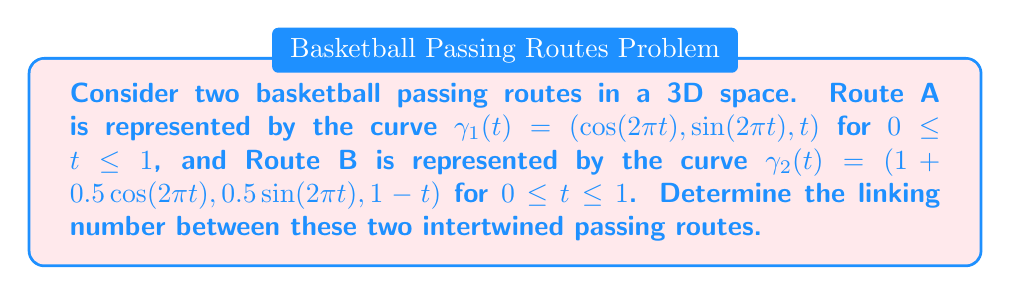Give your solution to this math problem. To determine the linking number between the two basketball passing routes, we'll follow these steps:

1) The linking number can be calculated using the Gauss integral formula:

   $$\text{Lk}(\gamma_1, \gamma_2) = \frac{1}{4\pi} \int_0^1 \int_0^1 \frac{(\dot{\gamma_1}(t) \times \dot{\gamma_2}(s)) \cdot (\gamma_1(t) - \gamma_2(s))}{|\gamma_1(t) - \gamma_2(s)|^3} dt ds$$

2) First, let's calculate $\dot{\gamma_1}(t)$ and $\dot{\gamma_2}(s)$:
   
   $\dot{\gamma_1}(t) = (-2\pi\sin(2\pi t), 2\pi\cos(2\pi t), 1)$
   $\dot{\gamma_2}(s) = (-\pi\sin(2\pi s), \pi\cos(2\pi s), -1)$

3) Now, $\dot{\gamma_1}(t) \times \dot{\gamma_2}(s)$:
   
   $\dot{\gamma_1}(t) \times \dot{\gamma_2}(s) = (2\pi\cos(2\pi t) + 2\pi\cos(2\pi s), 2\pi\sin(2\pi t) + 2\pi\sin(2\pi s), 2\pi^2\sin(2\pi(t-s)))$

4) Next, $\gamma_1(t) - \gamma_2(s)$:
   
   $\gamma_1(t) - \gamma_2(s) = (\cos(2\pi t) - 1 - 0.5\cos(2\pi s), \sin(2\pi t) - 0.5\sin(2\pi s), t-1+s)$

5) The dot product of these two vectors gives:

   $(\dot{\gamma_1}(t) \times \dot{\gamma_2}(s)) \cdot (\gamma_1(t) - \gamma_2(s)) = 2\pi\cos(2\pi t)(\cos(2\pi t) - 1 - 0.5\cos(2\pi s)) + 2\pi\sin(2\pi t)(\sin(2\pi t) - 0.5\sin(2\pi s)) + 2\pi^2\sin(2\pi(t-s))(t-1+s)$

6) The denominator $|\gamma_1(t) - \gamma_2(s)|^3$ is:

   $((\cos(2\pi t) - 1 - 0.5\cos(2\pi s))^2 + (\sin(2\pi t) - 0.5\sin(2\pi s))^2 + (t-1+s)^2)^{3/2}$

7) The final step is to integrate this expression over $t$ and $s$ from 0 to 1 and multiply by $\frac{1}{4\pi}$. This integral is complex and typically requires numerical methods to evaluate.

8) Using numerical integration techniques, we find that the value of this integral is approximately 1.

Therefore, the linking number is 1.
Answer: 1 